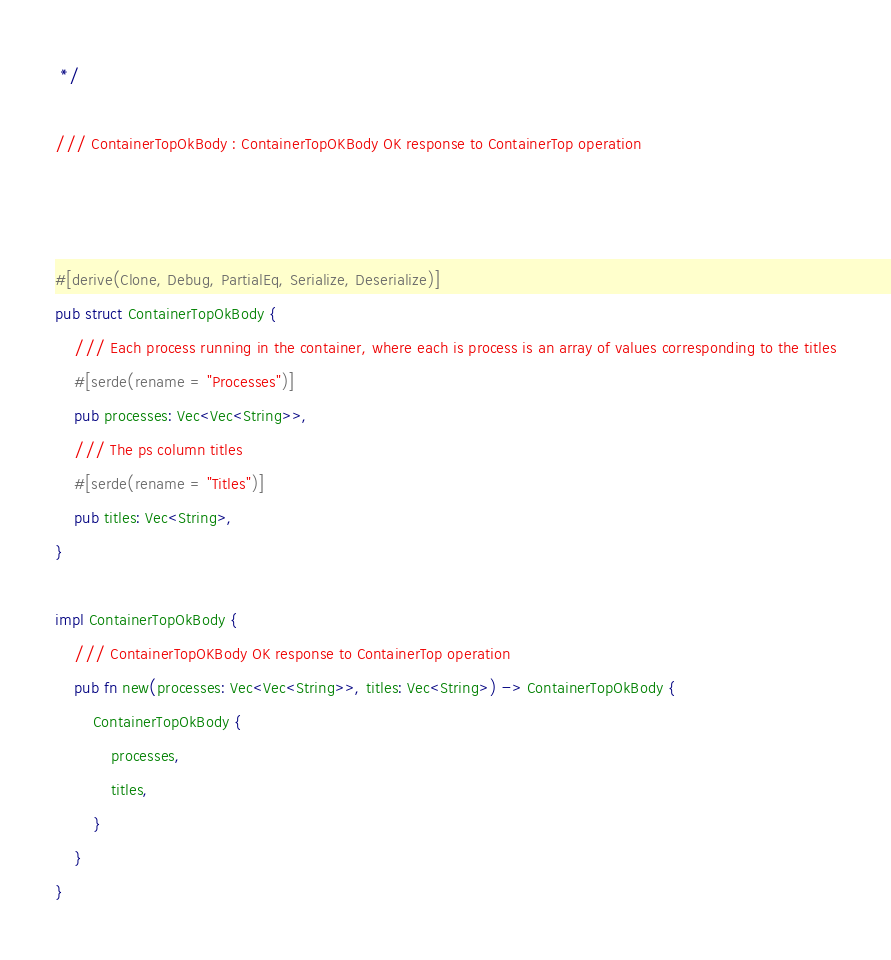<code> <loc_0><loc_0><loc_500><loc_500><_Rust_> */

/// ContainerTopOkBody : ContainerTopOKBody OK response to ContainerTop operation



#[derive(Clone, Debug, PartialEq, Serialize, Deserialize)]
pub struct ContainerTopOkBody {
    /// Each process running in the container, where each is process is an array of values corresponding to the titles
    #[serde(rename = "Processes")]
    pub processes: Vec<Vec<String>>,
    /// The ps column titles
    #[serde(rename = "Titles")]
    pub titles: Vec<String>,
}

impl ContainerTopOkBody {
    /// ContainerTopOKBody OK response to ContainerTop operation
    pub fn new(processes: Vec<Vec<String>>, titles: Vec<String>) -> ContainerTopOkBody {
        ContainerTopOkBody {
            processes,
            titles,
        }
    }
}


</code> 